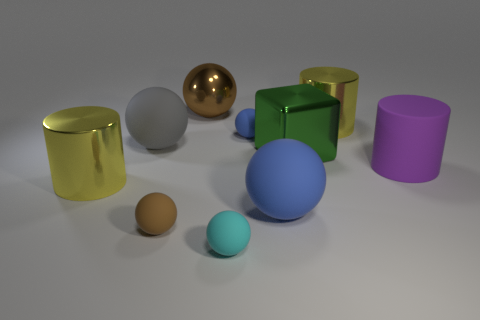Subtract all brown matte spheres. How many spheres are left? 5 Subtract all cyan balls. How many balls are left? 5 Subtract all cyan balls. Subtract all brown cylinders. How many balls are left? 5 Subtract all cylinders. How many objects are left? 7 Add 8 big gray rubber spheres. How many big gray rubber spheres are left? 9 Add 1 red metal balls. How many red metal balls exist? 1 Subtract 0 blue cylinders. How many objects are left? 10 Subtract all large yellow rubber blocks. Subtract all green metal cubes. How many objects are left? 9 